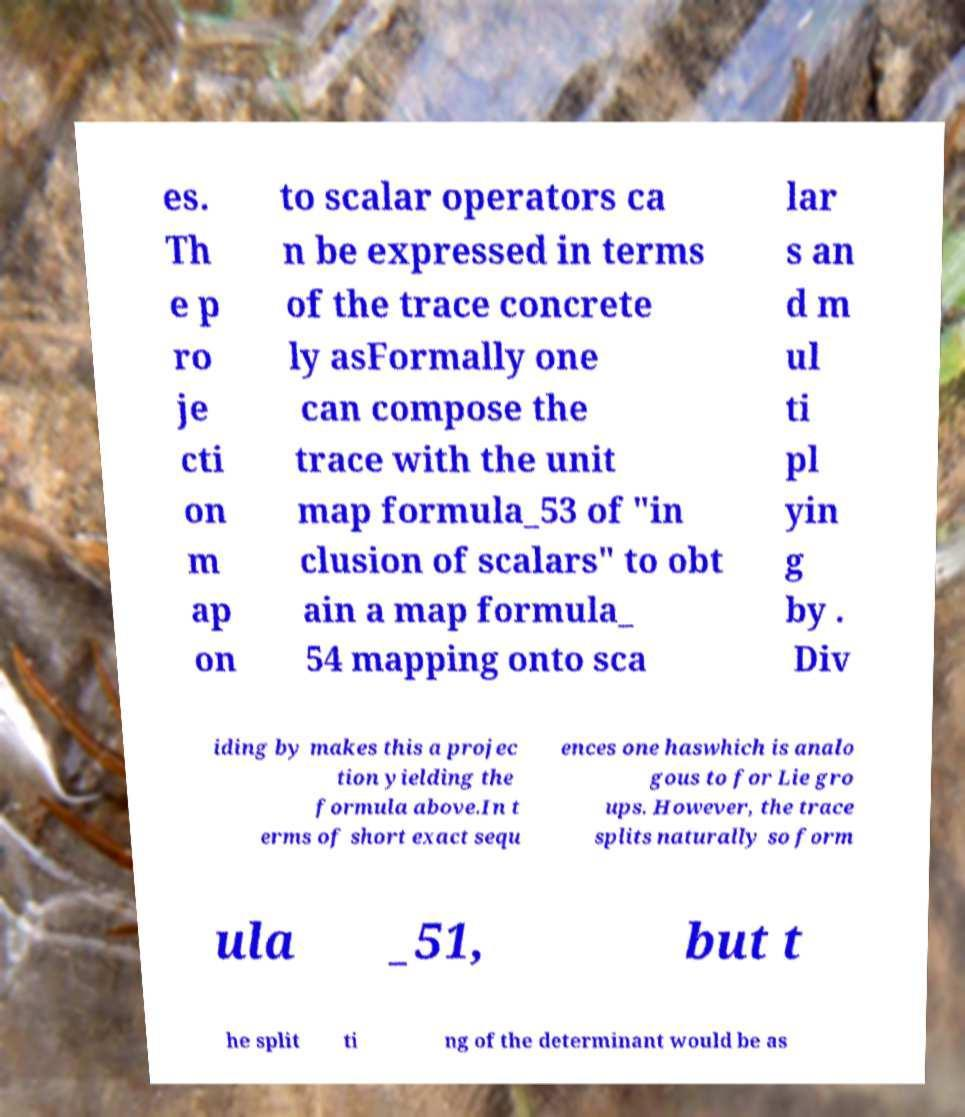Please read and relay the text visible in this image. What does it say? es. Th e p ro je cti on m ap on to scalar operators ca n be expressed in terms of the trace concrete ly asFormally one can compose the trace with the unit map formula_53 of "in clusion of scalars" to obt ain a map formula_ 54 mapping onto sca lar s an d m ul ti pl yin g by . Div iding by makes this a projec tion yielding the formula above.In t erms of short exact sequ ences one haswhich is analo gous to for Lie gro ups. However, the trace splits naturally so form ula _51, but t he split ti ng of the determinant would be as 